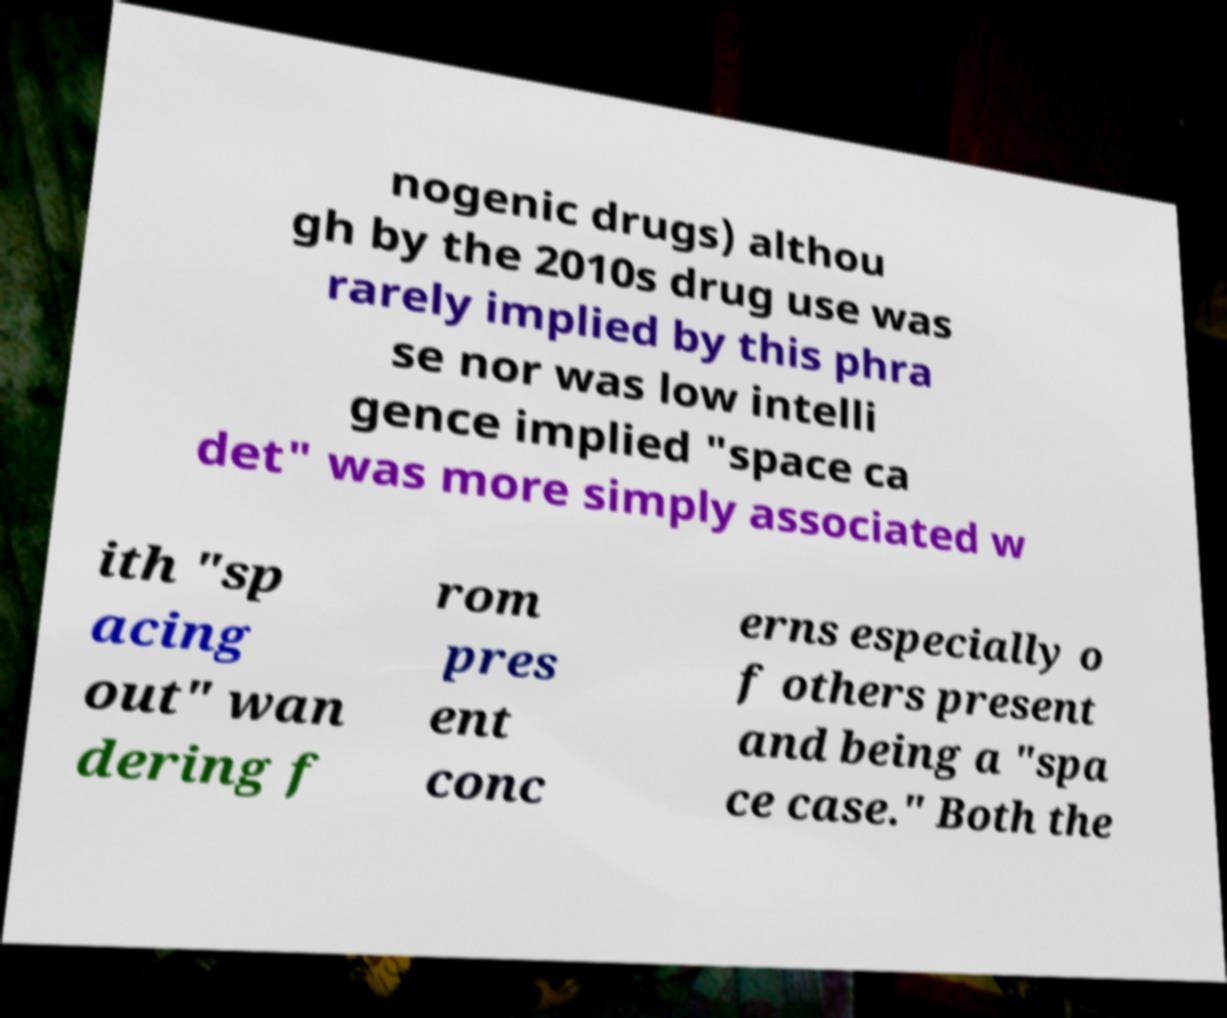Can you read and provide the text displayed in the image?This photo seems to have some interesting text. Can you extract and type it out for me? nogenic drugs) althou gh by the 2010s drug use was rarely implied by this phra se nor was low intelli gence implied "space ca det" was more simply associated w ith "sp acing out" wan dering f rom pres ent conc erns especially o f others present and being a "spa ce case." Both the 